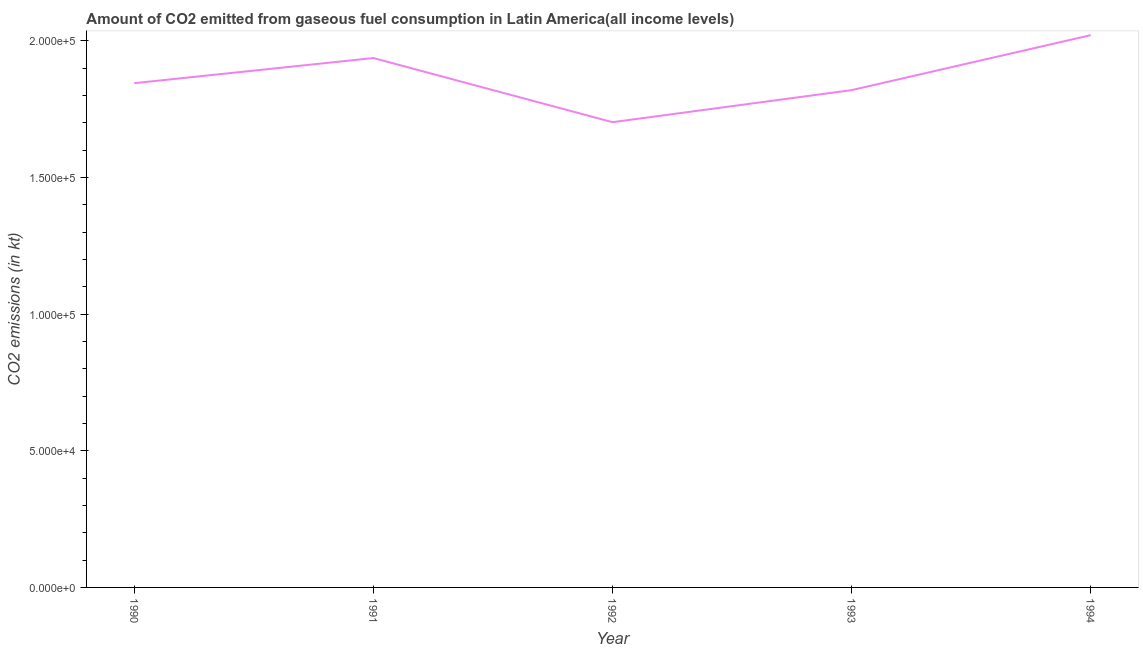What is the co2 emissions from gaseous fuel consumption in 1994?
Offer a terse response. 2.02e+05. Across all years, what is the maximum co2 emissions from gaseous fuel consumption?
Provide a succinct answer. 2.02e+05. Across all years, what is the minimum co2 emissions from gaseous fuel consumption?
Give a very brief answer. 1.70e+05. What is the sum of the co2 emissions from gaseous fuel consumption?
Provide a succinct answer. 9.33e+05. What is the difference between the co2 emissions from gaseous fuel consumption in 1991 and 1994?
Your answer should be very brief. -8366.89. What is the average co2 emissions from gaseous fuel consumption per year?
Provide a succinct answer. 1.87e+05. What is the median co2 emissions from gaseous fuel consumption?
Offer a very short reply. 1.85e+05. Do a majority of the years between 1994 and 1991 (inclusive) have co2 emissions from gaseous fuel consumption greater than 140000 kt?
Provide a short and direct response. Yes. What is the ratio of the co2 emissions from gaseous fuel consumption in 1990 to that in 1994?
Keep it short and to the point. 0.91. What is the difference between the highest and the second highest co2 emissions from gaseous fuel consumption?
Give a very brief answer. 8366.89. Is the sum of the co2 emissions from gaseous fuel consumption in 1992 and 1993 greater than the maximum co2 emissions from gaseous fuel consumption across all years?
Your answer should be very brief. Yes. What is the difference between the highest and the lowest co2 emissions from gaseous fuel consumption?
Your answer should be compact. 3.18e+04. In how many years, is the co2 emissions from gaseous fuel consumption greater than the average co2 emissions from gaseous fuel consumption taken over all years?
Give a very brief answer. 2. Does the co2 emissions from gaseous fuel consumption monotonically increase over the years?
Give a very brief answer. No. What is the difference between two consecutive major ticks on the Y-axis?
Make the answer very short. 5.00e+04. Does the graph contain grids?
Offer a terse response. No. What is the title of the graph?
Provide a succinct answer. Amount of CO2 emitted from gaseous fuel consumption in Latin America(all income levels). What is the label or title of the X-axis?
Make the answer very short. Year. What is the label or title of the Y-axis?
Keep it short and to the point. CO2 emissions (in kt). What is the CO2 emissions (in kt) in 1990?
Your response must be concise. 1.85e+05. What is the CO2 emissions (in kt) in 1991?
Your response must be concise. 1.94e+05. What is the CO2 emissions (in kt) of 1992?
Give a very brief answer. 1.70e+05. What is the CO2 emissions (in kt) of 1993?
Provide a short and direct response. 1.82e+05. What is the CO2 emissions (in kt) in 1994?
Keep it short and to the point. 2.02e+05. What is the difference between the CO2 emissions (in kt) in 1990 and 1991?
Your response must be concise. -9203.18. What is the difference between the CO2 emissions (in kt) in 1990 and 1992?
Keep it short and to the point. 1.43e+04. What is the difference between the CO2 emissions (in kt) in 1990 and 1993?
Provide a short and direct response. 2544.71. What is the difference between the CO2 emissions (in kt) in 1990 and 1994?
Keep it short and to the point. -1.76e+04. What is the difference between the CO2 emissions (in kt) in 1991 and 1992?
Provide a succinct answer. 2.35e+04. What is the difference between the CO2 emissions (in kt) in 1991 and 1993?
Give a very brief answer. 1.17e+04. What is the difference between the CO2 emissions (in kt) in 1991 and 1994?
Provide a short and direct response. -8366.89. What is the difference between the CO2 emissions (in kt) in 1992 and 1993?
Provide a short and direct response. -1.17e+04. What is the difference between the CO2 emissions (in kt) in 1992 and 1994?
Your answer should be very brief. -3.18e+04. What is the difference between the CO2 emissions (in kt) in 1993 and 1994?
Your answer should be very brief. -2.01e+04. What is the ratio of the CO2 emissions (in kt) in 1990 to that in 1991?
Your answer should be very brief. 0.95. What is the ratio of the CO2 emissions (in kt) in 1990 to that in 1992?
Provide a succinct answer. 1.08. What is the ratio of the CO2 emissions (in kt) in 1991 to that in 1992?
Make the answer very short. 1.14. What is the ratio of the CO2 emissions (in kt) in 1991 to that in 1993?
Offer a terse response. 1.06. What is the ratio of the CO2 emissions (in kt) in 1991 to that in 1994?
Offer a terse response. 0.96. What is the ratio of the CO2 emissions (in kt) in 1992 to that in 1993?
Your answer should be very brief. 0.94. What is the ratio of the CO2 emissions (in kt) in 1992 to that in 1994?
Ensure brevity in your answer.  0.84. What is the ratio of the CO2 emissions (in kt) in 1993 to that in 1994?
Make the answer very short. 0.9. 